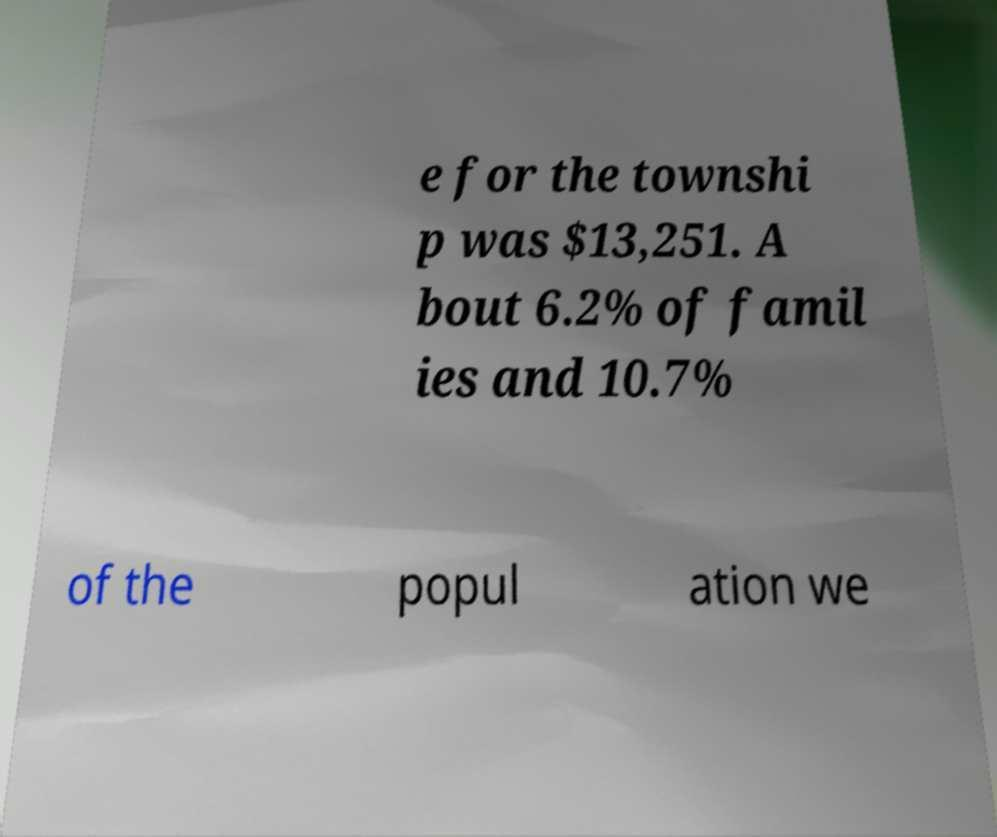I need the written content from this picture converted into text. Can you do that? e for the townshi p was $13,251. A bout 6.2% of famil ies and 10.7% of the popul ation we 